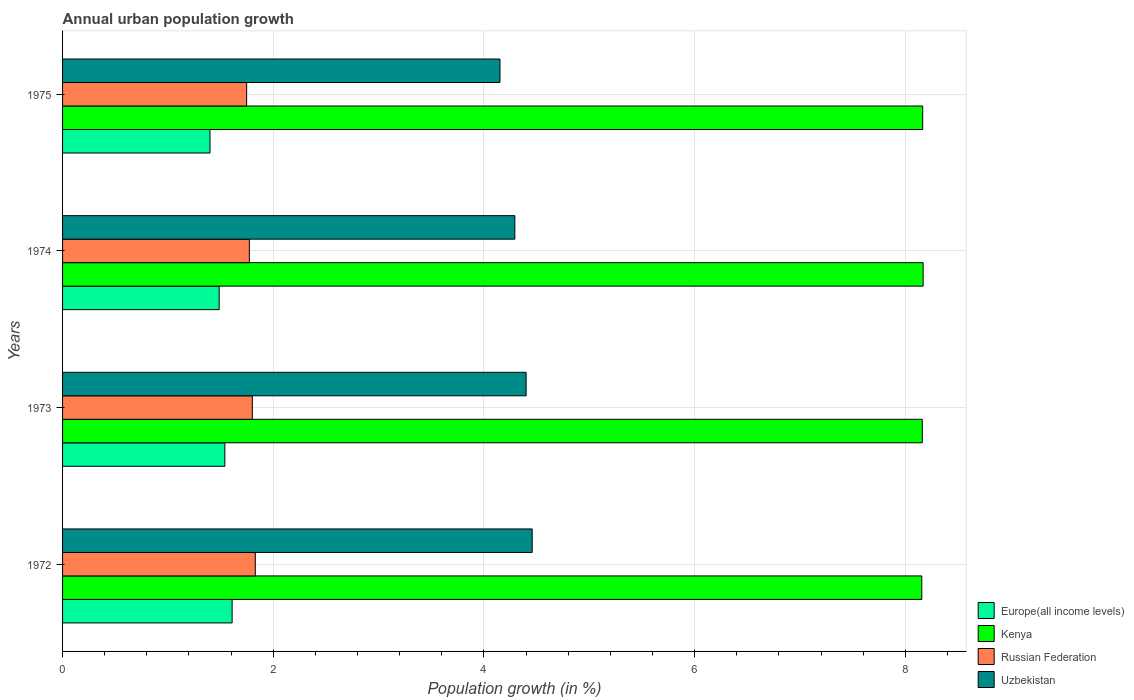How many different coloured bars are there?
Keep it short and to the point. 4. How many groups of bars are there?
Your answer should be very brief. 4. Are the number of bars on each tick of the Y-axis equal?
Make the answer very short. Yes. How many bars are there on the 3rd tick from the bottom?
Your answer should be very brief. 4. What is the label of the 1st group of bars from the top?
Your response must be concise. 1975. In how many cases, is the number of bars for a given year not equal to the number of legend labels?
Provide a succinct answer. 0. What is the percentage of urban population growth in Uzbekistan in 1975?
Offer a terse response. 4.15. Across all years, what is the maximum percentage of urban population growth in Kenya?
Provide a succinct answer. 8.17. Across all years, what is the minimum percentage of urban population growth in Europe(all income levels)?
Make the answer very short. 1.4. In which year was the percentage of urban population growth in Kenya maximum?
Give a very brief answer. 1974. In which year was the percentage of urban population growth in Uzbekistan minimum?
Provide a short and direct response. 1975. What is the total percentage of urban population growth in Europe(all income levels) in the graph?
Provide a succinct answer. 6.04. What is the difference between the percentage of urban population growth in Europe(all income levels) in 1972 and that in 1974?
Your answer should be very brief. 0.12. What is the difference between the percentage of urban population growth in Kenya in 1973 and the percentage of urban population growth in Uzbekistan in 1975?
Keep it short and to the point. 4.01. What is the average percentage of urban population growth in Uzbekistan per year?
Ensure brevity in your answer.  4.33. In the year 1975, what is the difference between the percentage of urban population growth in Kenya and percentage of urban population growth in Europe(all income levels)?
Offer a very short reply. 6.77. What is the ratio of the percentage of urban population growth in Kenya in 1974 to that in 1975?
Keep it short and to the point. 1. Is the percentage of urban population growth in Europe(all income levels) in 1974 less than that in 1975?
Provide a succinct answer. No. Is the difference between the percentage of urban population growth in Kenya in 1973 and 1975 greater than the difference between the percentage of urban population growth in Europe(all income levels) in 1973 and 1975?
Offer a very short reply. No. What is the difference between the highest and the second highest percentage of urban population growth in Russian Federation?
Offer a terse response. 0.03. What is the difference between the highest and the lowest percentage of urban population growth in Russian Federation?
Offer a terse response. 0.08. In how many years, is the percentage of urban population growth in Kenya greater than the average percentage of urban population growth in Kenya taken over all years?
Offer a terse response. 2. Is it the case that in every year, the sum of the percentage of urban population growth in Europe(all income levels) and percentage of urban population growth in Kenya is greater than the sum of percentage of urban population growth in Uzbekistan and percentage of urban population growth in Russian Federation?
Keep it short and to the point. Yes. What does the 1st bar from the top in 1972 represents?
Offer a very short reply. Uzbekistan. What does the 2nd bar from the bottom in 1973 represents?
Ensure brevity in your answer.  Kenya. How many bars are there?
Ensure brevity in your answer.  16. Are all the bars in the graph horizontal?
Give a very brief answer. Yes. What is the difference between two consecutive major ticks on the X-axis?
Offer a terse response. 2. Does the graph contain grids?
Your answer should be very brief. Yes. Where does the legend appear in the graph?
Give a very brief answer. Bottom right. How many legend labels are there?
Your response must be concise. 4. What is the title of the graph?
Keep it short and to the point. Annual urban population growth. What is the label or title of the X-axis?
Your response must be concise. Population growth (in %). What is the Population growth (in %) in Europe(all income levels) in 1972?
Your response must be concise. 1.61. What is the Population growth (in %) in Kenya in 1972?
Keep it short and to the point. 8.16. What is the Population growth (in %) of Russian Federation in 1972?
Your answer should be compact. 1.83. What is the Population growth (in %) in Uzbekistan in 1972?
Provide a short and direct response. 4.46. What is the Population growth (in %) of Europe(all income levels) in 1973?
Provide a short and direct response. 1.54. What is the Population growth (in %) of Kenya in 1973?
Your answer should be compact. 8.16. What is the Population growth (in %) of Russian Federation in 1973?
Make the answer very short. 1.8. What is the Population growth (in %) of Uzbekistan in 1973?
Provide a succinct answer. 4.4. What is the Population growth (in %) in Europe(all income levels) in 1974?
Offer a very short reply. 1.49. What is the Population growth (in %) in Kenya in 1974?
Your response must be concise. 8.17. What is the Population growth (in %) of Russian Federation in 1974?
Offer a terse response. 1.77. What is the Population growth (in %) in Uzbekistan in 1974?
Provide a succinct answer. 4.29. What is the Population growth (in %) in Europe(all income levels) in 1975?
Your answer should be very brief. 1.4. What is the Population growth (in %) in Kenya in 1975?
Offer a terse response. 8.17. What is the Population growth (in %) in Russian Federation in 1975?
Keep it short and to the point. 1.75. What is the Population growth (in %) in Uzbekistan in 1975?
Provide a short and direct response. 4.15. Across all years, what is the maximum Population growth (in %) in Europe(all income levels)?
Provide a short and direct response. 1.61. Across all years, what is the maximum Population growth (in %) in Kenya?
Keep it short and to the point. 8.17. Across all years, what is the maximum Population growth (in %) of Russian Federation?
Your answer should be compact. 1.83. Across all years, what is the maximum Population growth (in %) in Uzbekistan?
Offer a terse response. 4.46. Across all years, what is the minimum Population growth (in %) in Europe(all income levels)?
Offer a terse response. 1.4. Across all years, what is the minimum Population growth (in %) of Kenya?
Your response must be concise. 8.16. Across all years, what is the minimum Population growth (in %) of Russian Federation?
Offer a terse response. 1.75. Across all years, what is the minimum Population growth (in %) in Uzbekistan?
Provide a short and direct response. 4.15. What is the total Population growth (in %) of Europe(all income levels) in the graph?
Ensure brevity in your answer.  6.04. What is the total Population growth (in %) in Kenya in the graph?
Your response must be concise. 32.65. What is the total Population growth (in %) of Russian Federation in the graph?
Provide a short and direct response. 7.15. What is the total Population growth (in %) of Uzbekistan in the graph?
Offer a terse response. 17.3. What is the difference between the Population growth (in %) of Europe(all income levels) in 1972 and that in 1973?
Provide a short and direct response. 0.07. What is the difference between the Population growth (in %) in Kenya in 1972 and that in 1973?
Your answer should be compact. -0. What is the difference between the Population growth (in %) of Russian Federation in 1972 and that in 1973?
Provide a succinct answer. 0.03. What is the difference between the Population growth (in %) of Uzbekistan in 1972 and that in 1973?
Provide a succinct answer. 0.06. What is the difference between the Population growth (in %) of Europe(all income levels) in 1972 and that in 1974?
Offer a very short reply. 0.12. What is the difference between the Population growth (in %) of Kenya in 1972 and that in 1974?
Ensure brevity in your answer.  -0.01. What is the difference between the Population growth (in %) of Russian Federation in 1972 and that in 1974?
Offer a terse response. 0.06. What is the difference between the Population growth (in %) in Uzbekistan in 1972 and that in 1974?
Keep it short and to the point. 0.16. What is the difference between the Population growth (in %) in Europe(all income levels) in 1972 and that in 1975?
Your response must be concise. 0.21. What is the difference between the Population growth (in %) of Kenya in 1972 and that in 1975?
Ensure brevity in your answer.  -0.01. What is the difference between the Population growth (in %) in Russian Federation in 1972 and that in 1975?
Your response must be concise. 0.08. What is the difference between the Population growth (in %) in Uzbekistan in 1972 and that in 1975?
Give a very brief answer. 0.31. What is the difference between the Population growth (in %) of Europe(all income levels) in 1973 and that in 1974?
Provide a short and direct response. 0.05. What is the difference between the Population growth (in %) in Kenya in 1973 and that in 1974?
Your answer should be compact. -0.01. What is the difference between the Population growth (in %) of Russian Federation in 1973 and that in 1974?
Ensure brevity in your answer.  0.03. What is the difference between the Population growth (in %) of Uzbekistan in 1973 and that in 1974?
Make the answer very short. 0.11. What is the difference between the Population growth (in %) of Europe(all income levels) in 1973 and that in 1975?
Your answer should be very brief. 0.14. What is the difference between the Population growth (in %) of Kenya in 1973 and that in 1975?
Your answer should be compact. -0. What is the difference between the Population growth (in %) of Russian Federation in 1973 and that in 1975?
Ensure brevity in your answer.  0.05. What is the difference between the Population growth (in %) in Uzbekistan in 1973 and that in 1975?
Your response must be concise. 0.25. What is the difference between the Population growth (in %) in Europe(all income levels) in 1974 and that in 1975?
Provide a short and direct response. 0.09. What is the difference between the Population growth (in %) of Kenya in 1974 and that in 1975?
Your answer should be very brief. 0. What is the difference between the Population growth (in %) of Russian Federation in 1974 and that in 1975?
Provide a short and direct response. 0.03. What is the difference between the Population growth (in %) in Uzbekistan in 1974 and that in 1975?
Provide a succinct answer. 0.14. What is the difference between the Population growth (in %) of Europe(all income levels) in 1972 and the Population growth (in %) of Kenya in 1973?
Your answer should be very brief. -6.55. What is the difference between the Population growth (in %) in Europe(all income levels) in 1972 and the Population growth (in %) in Russian Federation in 1973?
Your response must be concise. -0.19. What is the difference between the Population growth (in %) of Europe(all income levels) in 1972 and the Population growth (in %) of Uzbekistan in 1973?
Provide a succinct answer. -2.79. What is the difference between the Population growth (in %) of Kenya in 1972 and the Population growth (in %) of Russian Federation in 1973?
Your response must be concise. 6.36. What is the difference between the Population growth (in %) in Kenya in 1972 and the Population growth (in %) in Uzbekistan in 1973?
Make the answer very short. 3.76. What is the difference between the Population growth (in %) in Russian Federation in 1972 and the Population growth (in %) in Uzbekistan in 1973?
Your answer should be very brief. -2.57. What is the difference between the Population growth (in %) of Europe(all income levels) in 1972 and the Population growth (in %) of Kenya in 1974?
Provide a short and direct response. -6.56. What is the difference between the Population growth (in %) in Europe(all income levels) in 1972 and the Population growth (in %) in Russian Federation in 1974?
Make the answer very short. -0.16. What is the difference between the Population growth (in %) of Europe(all income levels) in 1972 and the Population growth (in %) of Uzbekistan in 1974?
Offer a very short reply. -2.68. What is the difference between the Population growth (in %) in Kenya in 1972 and the Population growth (in %) in Russian Federation in 1974?
Your answer should be compact. 6.38. What is the difference between the Population growth (in %) of Kenya in 1972 and the Population growth (in %) of Uzbekistan in 1974?
Keep it short and to the point. 3.86. What is the difference between the Population growth (in %) of Russian Federation in 1972 and the Population growth (in %) of Uzbekistan in 1974?
Provide a succinct answer. -2.46. What is the difference between the Population growth (in %) in Europe(all income levels) in 1972 and the Population growth (in %) in Kenya in 1975?
Offer a very short reply. -6.56. What is the difference between the Population growth (in %) of Europe(all income levels) in 1972 and the Population growth (in %) of Russian Federation in 1975?
Provide a succinct answer. -0.14. What is the difference between the Population growth (in %) in Europe(all income levels) in 1972 and the Population growth (in %) in Uzbekistan in 1975?
Your response must be concise. -2.54. What is the difference between the Population growth (in %) of Kenya in 1972 and the Population growth (in %) of Russian Federation in 1975?
Provide a succinct answer. 6.41. What is the difference between the Population growth (in %) in Kenya in 1972 and the Population growth (in %) in Uzbekistan in 1975?
Give a very brief answer. 4. What is the difference between the Population growth (in %) in Russian Federation in 1972 and the Population growth (in %) in Uzbekistan in 1975?
Provide a succinct answer. -2.32. What is the difference between the Population growth (in %) in Europe(all income levels) in 1973 and the Population growth (in %) in Kenya in 1974?
Provide a succinct answer. -6.63. What is the difference between the Population growth (in %) in Europe(all income levels) in 1973 and the Population growth (in %) in Russian Federation in 1974?
Give a very brief answer. -0.23. What is the difference between the Population growth (in %) of Europe(all income levels) in 1973 and the Population growth (in %) of Uzbekistan in 1974?
Provide a succinct answer. -2.75. What is the difference between the Population growth (in %) in Kenya in 1973 and the Population growth (in %) in Russian Federation in 1974?
Provide a succinct answer. 6.39. What is the difference between the Population growth (in %) in Kenya in 1973 and the Population growth (in %) in Uzbekistan in 1974?
Ensure brevity in your answer.  3.87. What is the difference between the Population growth (in %) of Russian Federation in 1973 and the Population growth (in %) of Uzbekistan in 1974?
Provide a short and direct response. -2.49. What is the difference between the Population growth (in %) in Europe(all income levels) in 1973 and the Population growth (in %) in Kenya in 1975?
Give a very brief answer. -6.62. What is the difference between the Population growth (in %) of Europe(all income levels) in 1973 and the Population growth (in %) of Russian Federation in 1975?
Ensure brevity in your answer.  -0.21. What is the difference between the Population growth (in %) in Europe(all income levels) in 1973 and the Population growth (in %) in Uzbekistan in 1975?
Your answer should be compact. -2.61. What is the difference between the Population growth (in %) in Kenya in 1973 and the Population growth (in %) in Russian Federation in 1975?
Offer a very short reply. 6.41. What is the difference between the Population growth (in %) of Kenya in 1973 and the Population growth (in %) of Uzbekistan in 1975?
Give a very brief answer. 4.01. What is the difference between the Population growth (in %) of Russian Federation in 1973 and the Population growth (in %) of Uzbekistan in 1975?
Your answer should be very brief. -2.35. What is the difference between the Population growth (in %) of Europe(all income levels) in 1974 and the Population growth (in %) of Kenya in 1975?
Your response must be concise. -6.68. What is the difference between the Population growth (in %) of Europe(all income levels) in 1974 and the Population growth (in %) of Russian Federation in 1975?
Ensure brevity in your answer.  -0.26. What is the difference between the Population growth (in %) in Europe(all income levels) in 1974 and the Population growth (in %) in Uzbekistan in 1975?
Your answer should be compact. -2.67. What is the difference between the Population growth (in %) of Kenya in 1974 and the Population growth (in %) of Russian Federation in 1975?
Give a very brief answer. 6.42. What is the difference between the Population growth (in %) of Kenya in 1974 and the Population growth (in %) of Uzbekistan in 1975?
Keep it short and to the point. 4.02. What is the difference between the Population growth (in %) in Russian Federation in 1974 and the Population growth (in %) in Uzbekistan in 1975?
Your answer should be very brief. -2.38. What is the average Population growth (in %) of Europe(all income levels) per year?
Offer a very short reply. 1.51. What is the average Population growth (in %) in Kenya per year?
Your answer should be compact. 8.16. What is the average Population growth (in %) in Russian Federation per year?
Make the answer very short. 1.79. What is the average Population growth (in %) in Uzbekistan per year?
Keep it short and to the point. 4.33. In the year 1972, what is the difference between the Population growth (in %) of Europe(all income levels) and Population growth (in %) of Kenya?
Keep it short and to the point. -6.55. In the year 1972, what is the difference between the Population growth (in %) of Europe(all income levels) and Population growth (in %) of Russian Federation?
Provide a short and direct response. -0.22. In the year 1972, what is the difference between the Population growth (in %) in Europe(all income levels) and Population growth (in %) in Uzbekistan?
Your response must be concise. -2.85. In the year 1972, what is the difference between the Population growth (in %) of Kenya and Population growth (in %) of Russian Federation?
Offer a terse response. 6.33. In the year 1972, what is the difference between the Population growth (in %) of Kenya and Population growth (in %) of Uzbekistan?
Provide a short and direct response. 3.7. In the year 1972, what is the difference between the Population growth (in %) in Russian Federation and Population growth (in %) in Uzbekistan?
Make the answer very short. -2.63. In the year 1973, what is the difference between the Population growth (in %) of Europe(all income levels) and Population growth (in %) of Kenya?
Make the answer very short. -6.62. In the year 1973, what is the difference between the Population growth (in %) in Europe(all income levels) and Population growth (in %) in Russian Federation?
Your response must be concise. -0.26. In the year 1973, what is the difference between the Population growth (in %) of Europe(all income levels) and Population growth (in %) of Uzbekistan?
Your answer should be very brief. -2.86. In the year 1973, what is the difference between the Population growth (in %) in Kenya and Population growth (in %) in Russian Federation?
Offer a terse response. 6.36. In the year 1973, what is the difference between the Population growth (in %) of Kenya and Population growth (in %) of Uzbekistan?
Make the answer very short. 3.76. In the year 1973, what is the difference between the Population growth (in %) of Russian Federation and Population growth (in %) of Uzbekistan?
Your answer should be compact. -2.6. In the year 1974, what is the difference between the Population growth (in %) of Europe(all income levels) and Population growth (in %) of Kenya?
Your answer should be very brief. -6.68. In the year 1974, what is the difference between the Population growth (in %) in Europe(all income levels) and Population growth (in %) in Russian Federation?
Give a very brief answer. -0.29. In the year 1974, what is the difference between the Population growth (in %) of Europe(all income levels) and Population growth (in %) of Uzbekistan?
Offer a terse response. -2.81. In the year 1974, what is the difference between the Population growth (in %) in Kenya and Population growth (in %) in Russian Federation?
Offer a terse response. 6.4. In the year 1974, what is the difference between the Population growth (in %) in Kenya and Population growth (in %) in Uzbekistan?
Offer a very short reply. 3.88. In the year 1974, what is the difference between the Population growth (in %) of Russian Federation and Population growth (in %) of Uzbekistan?
Make the answer very short. -2.52. In the year 1975, what is the difference between the Population growth (in %) of Europe(all income levels) and Population growth (in %) of Kenya?
Keep it short and to the point. -6.77. In the year 1975, what is the difference between the Population growth (in %) of Europe(all income levels) and Population growth (in %) of Russian Federation?
Give a very brief answer. -0.35. In the year 1975, what is the difference between the Population growth (in %) in Europe(all income levels) and Population growth (in %) in Uzbekistan?
Your response must be concise. -2.75. In the year 1975, what is the difference between the Population growth (in %) of Kenya and Population growth (in %) of Russian Federation?
Offer a very short reply. 6.42. In the year 1975, what is the difference between the Population growth (in %) in Kenya and Population growth (in %) in Uzbekistan?
Give a very brief answer. 4.01. In the year 1975, what is the difference between the Population growth (in %) of Russian Federation and Population growth (in %) of Uzbekistan?
Your answer should be very brief. -2.4. What is the ratio of the Population growth (in %) of Europe(all income levels) in 1972 to that in 1973?
Keep it short and to the point. 1.04. What is the ratio of the Population growth (in %) in Kenya in 1972 to that in 1973?
Ensure brevity in your answer.  1. What is the ratio of the Population growth (in %) in Russian Federation in 1972 to that in 1973?
Offer a very short reply. 1.02. What is the ratio of the Population growth (in %) in Europe(all income levels) in 1972 to that in 1974?
Give a very brief answer. 1.08. What is the ratio of the Population growth (in %) in Kenya in 1972 to that in 1974?
Provide a succinct answer. 1. What is the ratio of the Population growth (in %) in Russian Federation in 1972 to that in 1974?
Ensure brevity in your answer.  1.03. What is the ratio of the Population growth (in %) in Uzbekistan in 1972 to that in 1974?
Your answer should be very brief. 1.04. What is the ratio of the Population growth (in %) in Europe(all income levels) in 1972 to that in 1975?
Offer a terse response. 1.15. What is the ratio of the Population growth (in %) of Kenya in 1972 to that in 1975?
Your response must be concise. 1. What is the ratio of the Population growth (in %) in Russian Federation in 1972 to that in 1975?
Provide a succinct answer. 1.05. What is the ratio of the Population growth (in %) of Uzbekistan in 1972 to that in 1975?
Offer a very short reply. 1.07. What is the ratio of the Population growth (in %) in Europe(all income levels) in 1973 to that in 1974?
Make the answer very short. 1.04. What is the ratio of the Population growth (in %) of Kenya in 1973 to that in 1974?
Provide a short and direct response. 1. What is the ratio of the Population growth (in %) in Russian Federation in 1973 to that in 1974?
Keep it short and to the point. 1.02. What is the ratio of the Population growth (in %) of Europe(all income levels) in 1973 to that in 1975?
Offer a terse response. 1.1. What is the ratio of the Population growth (in %) of Russian Federation in 1973 to that in 1975?
Give a very brief answer. 1.03. What is the ratio of the Population growth (in %) of Uzbekistan in 1973 to that in 1975?
Keep it short and to the point. 1.06. What is the ratio of the Population growth (in %) of Europe(all income levels) in 1974 to that in 1975?
Your answer should be very brief. 1.06. What is the ratio of the Population growth (in %) in Russian Federation in 1974 to that in 1975?
Your response must be concise. 1.01. What is the ratio of the Population growth (in %) in Uzbekistan in 1974 to that in 1975?
Your answer should be very brief. 1.03. What is the difference between the highest and the second highest Population growth (in %) in Europe(all income levels)?
Offer a very short reply. 0.07. What is the difference between the highest and the second highest Population growth (in %) in Kenya?
Ensure brevity in your answer.  0. What is the difference between the highest and the second highest Population growth (in %) of Russian Federation?
Offer a terse response. 0.03. What is the difference between the highest and the second highest Population growth (in %) of Uzbekistan?
Keep it short and to the point. 0.06. What is the difference between the highest and the lowest Population growth (in %) in Europe(all income levels)?
Ensure brevity in your answer.  0.21. What is the difference between the highest and the lowest Population growth (in %) in Kenya?
Give a very brief answer. 0.01. What is the difference between the highest and the lowest Population growth (in %) in Russian Federation?
Your response must be concise. 0.08. What is the difference between the highest and the lowest Population growth (in %) of Uzbekistan?
Offer a very short reply. 0.31. 